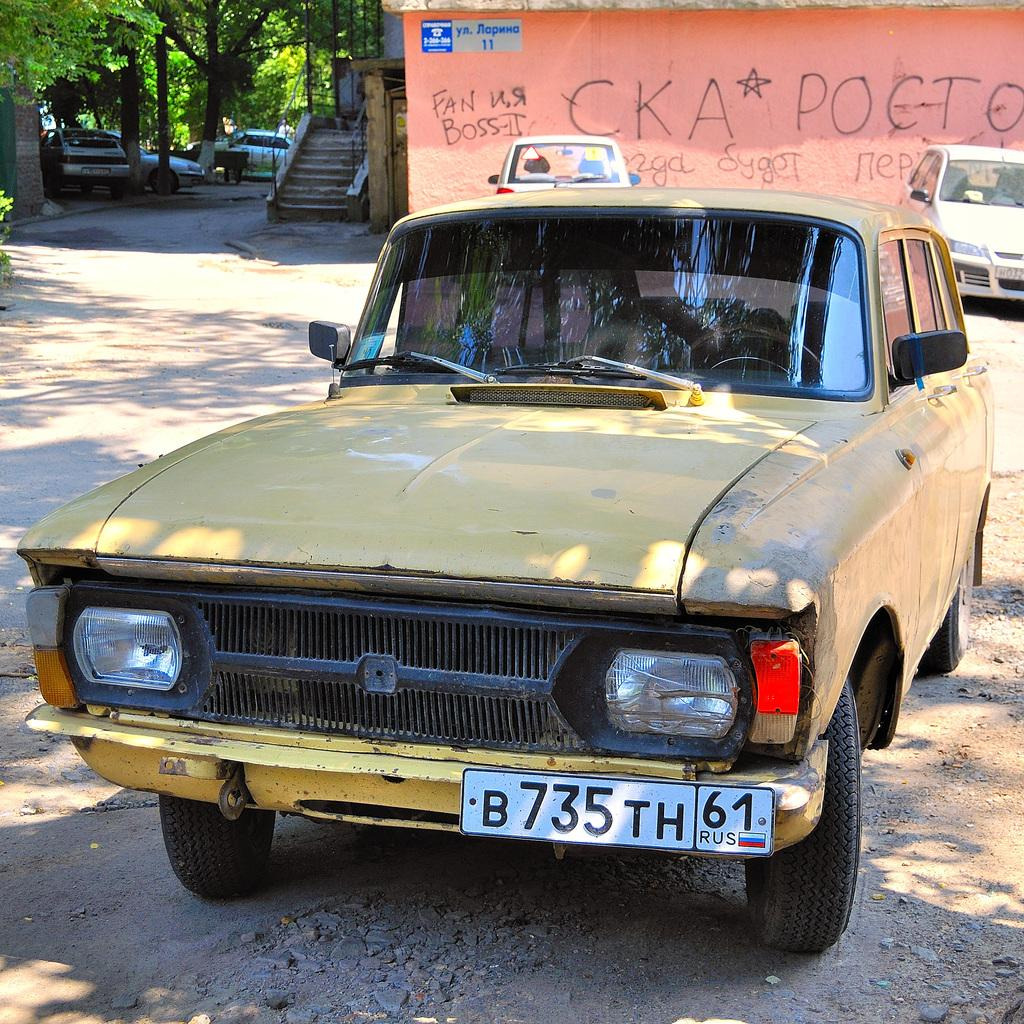<image>
Provide a brief description of the given image. A foreign car with a liscence plate that says B735 TH 61. 